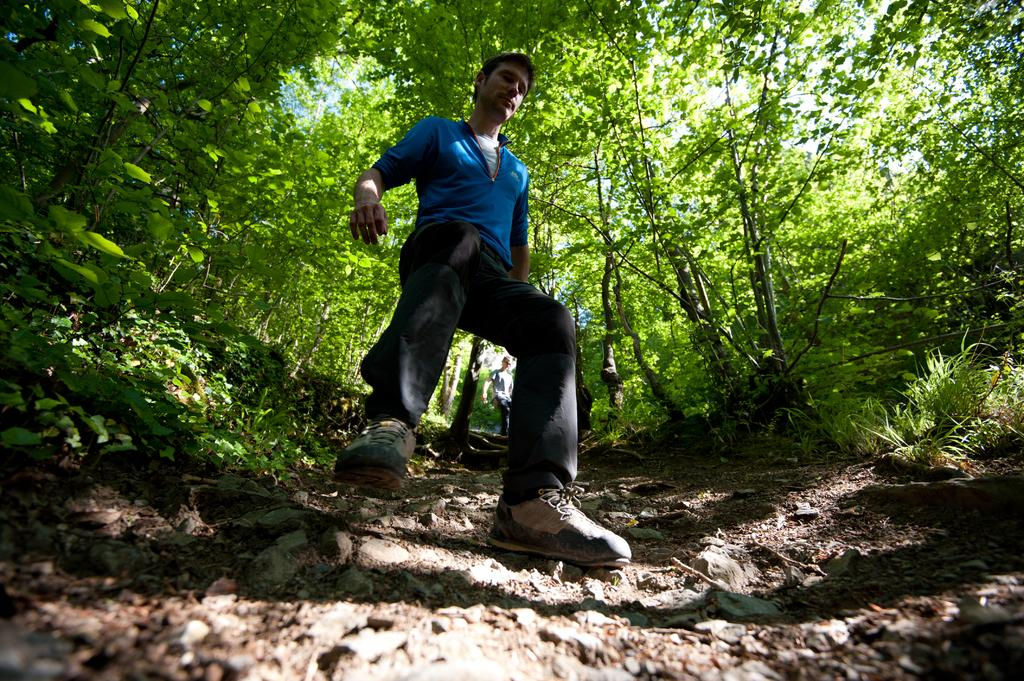Who or what is present in the image? There are people in the image. What type of natural environment is depicted in the image? There are many trees and plants in the image, indicating a natural setting. What can be seen in the sky in the image? The sky is visible in the image. What type of ground surface is shown in the image? There are stones in the image, suggesting a rocky or uneven ground surface. What type of crime is being committed in the image? There is no indication of any crime being committed in the image. What type of business is being conducted in the image? There is no indication of any business being conducted in the image. 